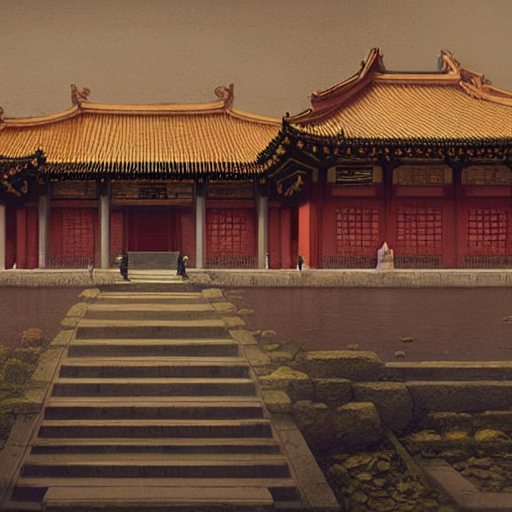What type of picture is this? The image appears to be digitally generated, resembling a scene one might find in a video game or a stylized illustration due to its color palette and the level of detail. It doesn't exhibit the visual cues typically associated with a conventional photograph, such as lens flare, depth of field, or the natural gradation of light one expects from a photo taken by a professional photographer in a real-world setting. 